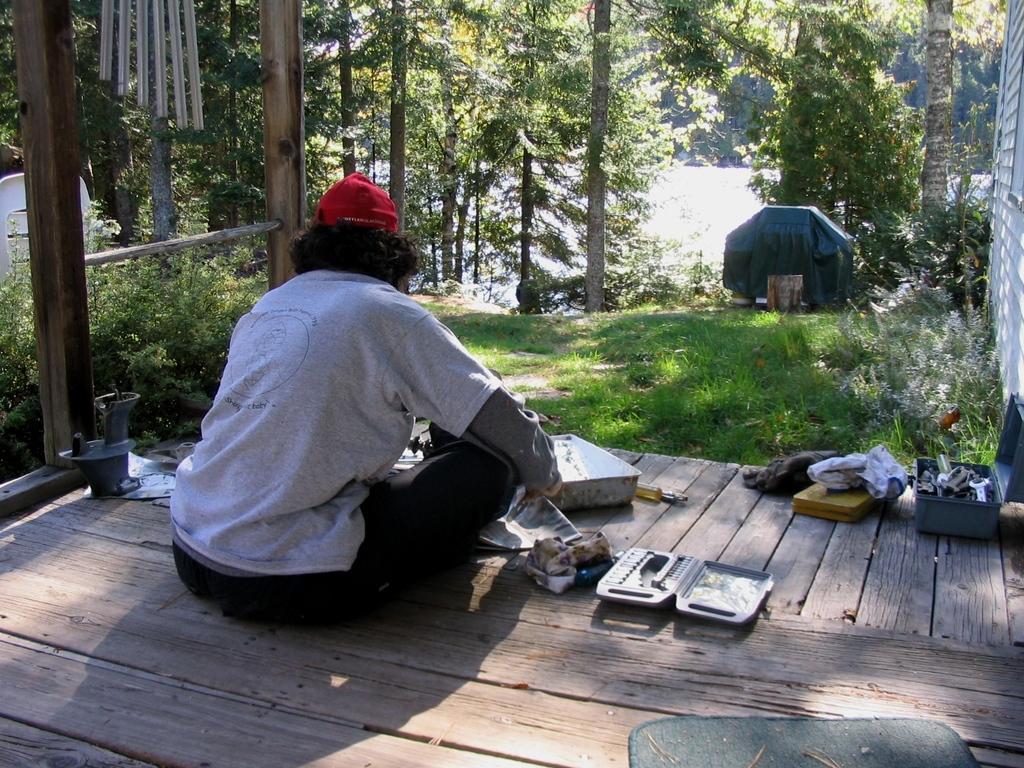Can you describe this image briefly? In this image a person wearing a cap is sitting on the wooden floor having a box and few objects on it. In the box there are few metal objects. Before the him there is grassland having few plants and trees. Right side there is a wall. Middle of the image there is water. Beside there are few trees. There is an object on the grassland. 